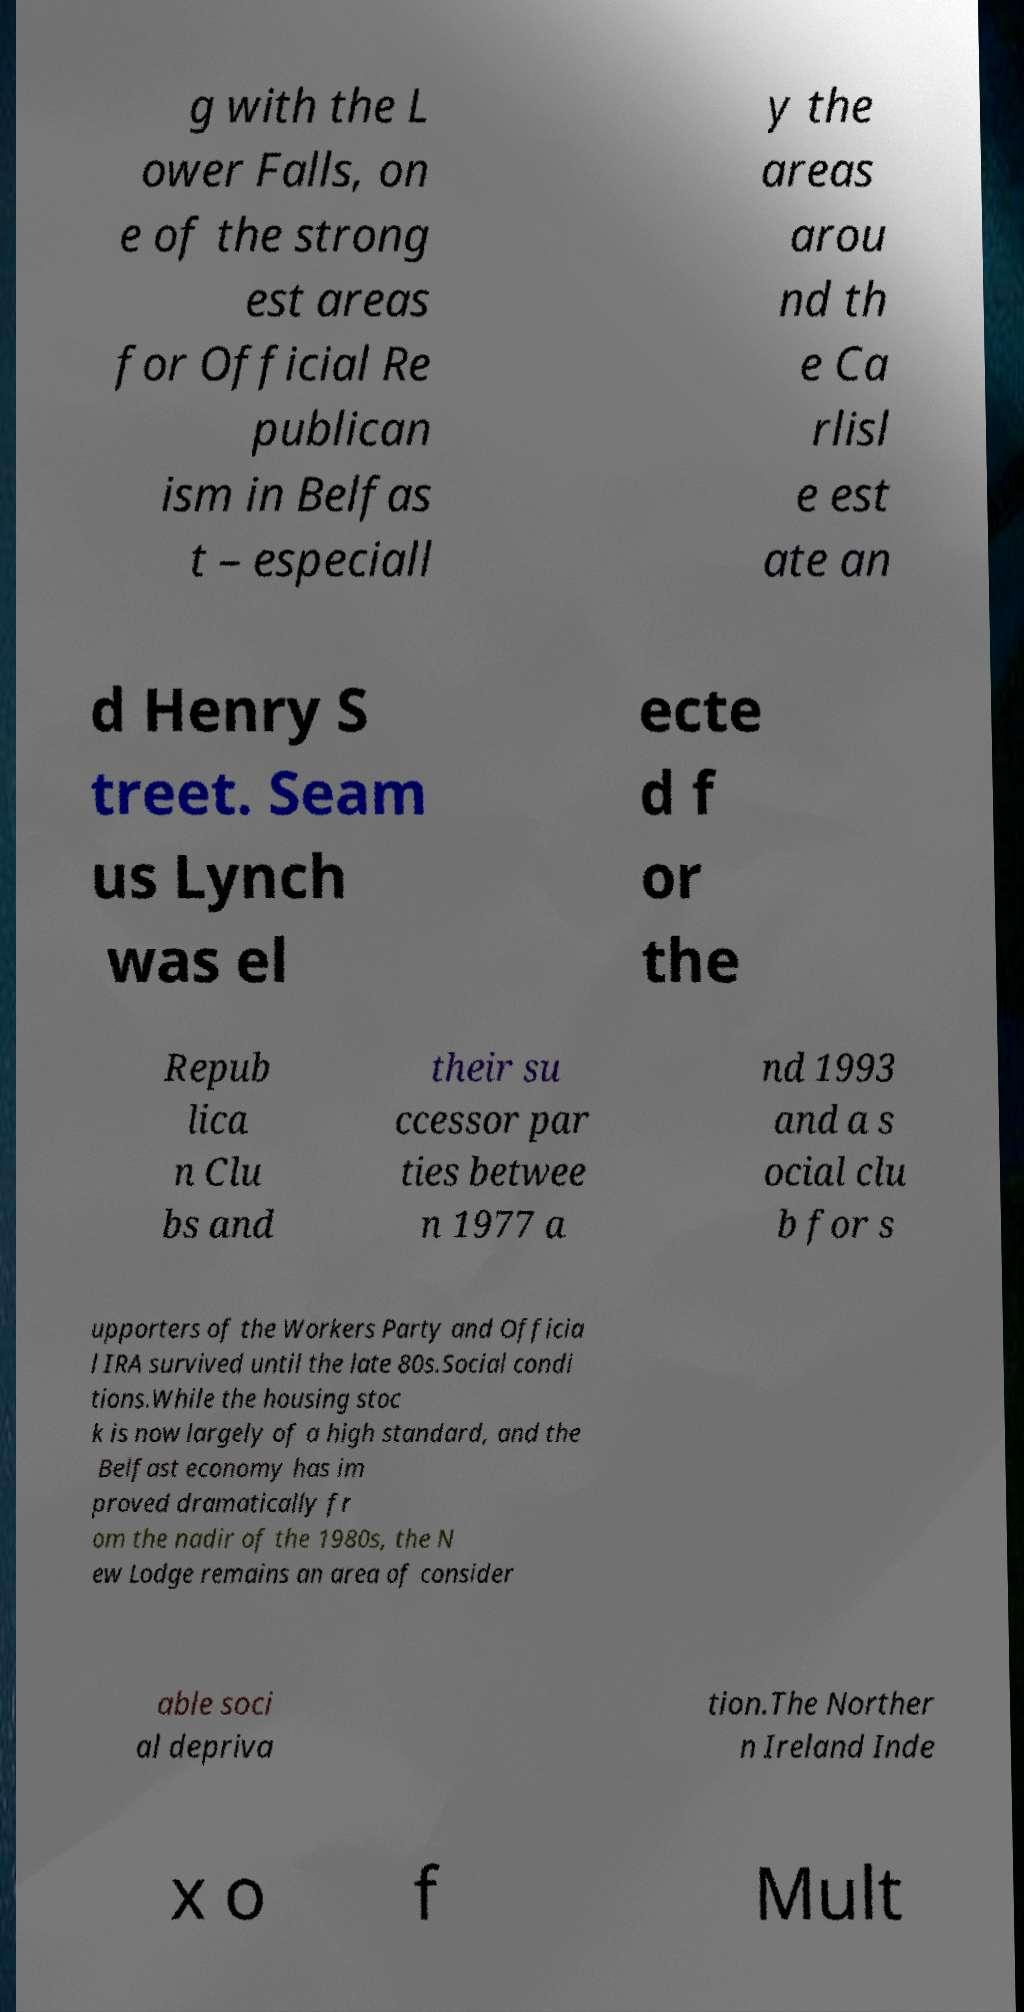I need the written content from this picture converted into text. Can you do that? g with the L ower Falls, on e of the strong est areas for Official Re publican ism in Belfas t – especiall y the areas arou nd th e Ca rlisl e est ate an d Henry S treet. Seam us Lynch was el ecte d f or the Repub lica n Clu bs and their su ccessor par ties betwee n 1977 a nd 1993 and a s ocial clu b for s upporters of the Workers Party and Officia l IRA survived until the late 80s.Social condi tions.While the housing stoc k is now largely of a high standard, and the Belfast economy has im proved dramatically fr om the nadir of the 1980s, the N ew Lodge remains an area of consider able soci al depriva tion.The Norther n Ireland Inde x o f Mult 